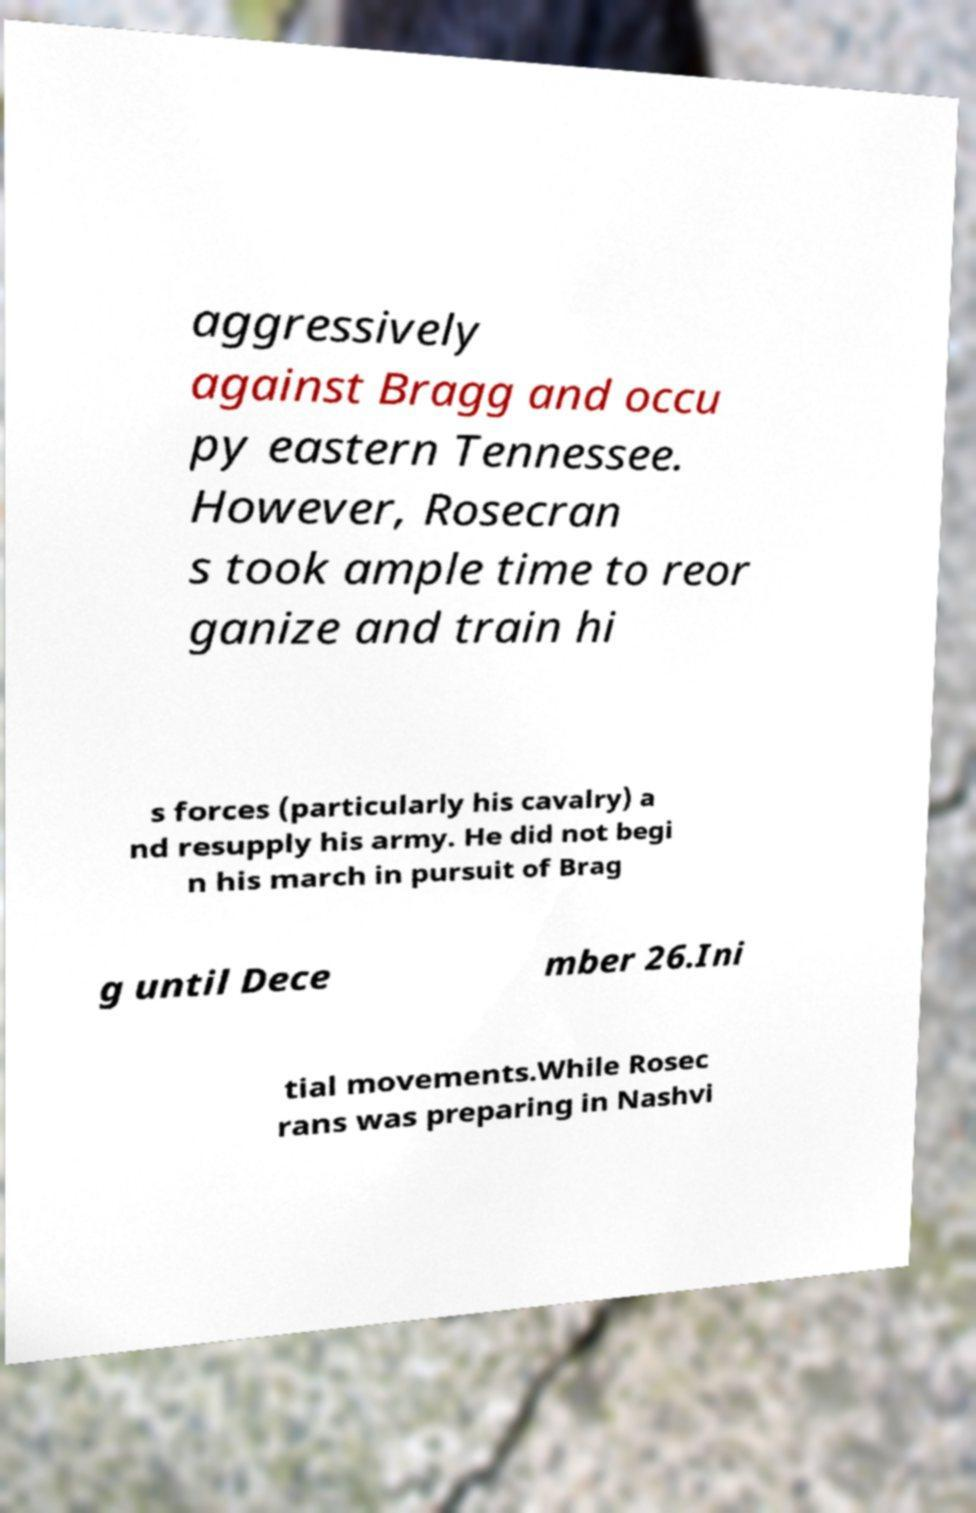Can you read and provide the text displayed in the image?This photo seems to have some interesting text. Can you extract and type it out for me? aggressively against Bragg and occu py eastern Tennessee. However, Rosecran s took ample time to reor ganize and train hi s forces (particularly his cavalry) a nd resupply his army. He did not begi n his march in pursuit of Brag g until Dece mber 26.Ini tial movements.While Rosec rans was preparing in Nashvi 